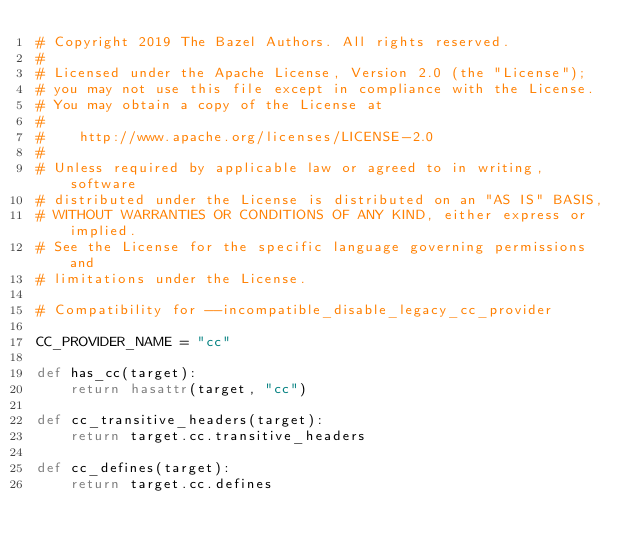Convert code to text. <code><loc_0><loc_0><loc_500><loc_500><_Python_># Copyright 2019 The Bazel Authors. All rights reserved.
#
# Licensed under the Apache License, Version 2.0 (the "License");
# you may not use this file except in compliance with the License.
# You may obtain a copy of the License at
#
#    http://www.apache.org/licenses/LICENSE-2.0
#
# Unless required by applicable law or agreed to in writing, software
# distributed under the License is distributed on an "AS IS" BASIS,
# WITHOUT WARRANTIES OR CONDITIONS OF ANY KIND, either express or implied.
# See the License for the specific language governing permissions and
# limitations under the License.

# Compatibility for --incompatible_disable_legacy_cc_provider

CC_PROVIDER_NAME = "cc"

def has_cc(target):
    return hasattr(target, "cc")

def cc_transitive_headers(target):
    return target.cc.transitive_headers

def cc_defines(target):
    return target.cc.defines
</code> 